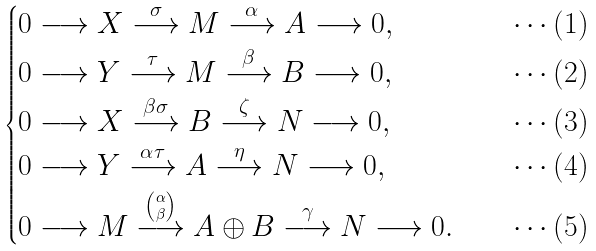Convert formula to latex. <formula><loc_0><loc_0><loc_500><loc_500>\begin{cases} 0 \longrightarrow X \overset { \sigma } { \longrightarrow } M \overset { \alpha } { \longrightarrow } A \longrightarrow 0 , & \quad \cdots ( 1 ) \\ 0 \longrightarrow Y \overset { \tau } { \longrightarrow } M \overset { \beta } { \longrightarrow } B \longrightarrow 0 , & \quad \cdots ( 2 ) \\ 0 \longrightarrow X \overset { \beta \sigma } { \longrightarrow } B \overset { \zeta } { \longrightarrow } N \longrightarrow 0 , & \quad \cdots ( 3 ) \\ 0 \longrightarrow Y \overset { \alpha \tau } { \longrightarrow } A \overset { \eta } { \longrightarrow } N \longrightarrow 0 , & \quad \cdots ( 4 ) \\ 0 \longrightarrow M \overset { \binom { \alpha } { \beta } } { \longrightarrow } A \oplus B \overset { \gamma } { \longrightarrow } N \longrightarrow 0 . & \quad \cdots ( 5 ) \end{cases}</formula> 